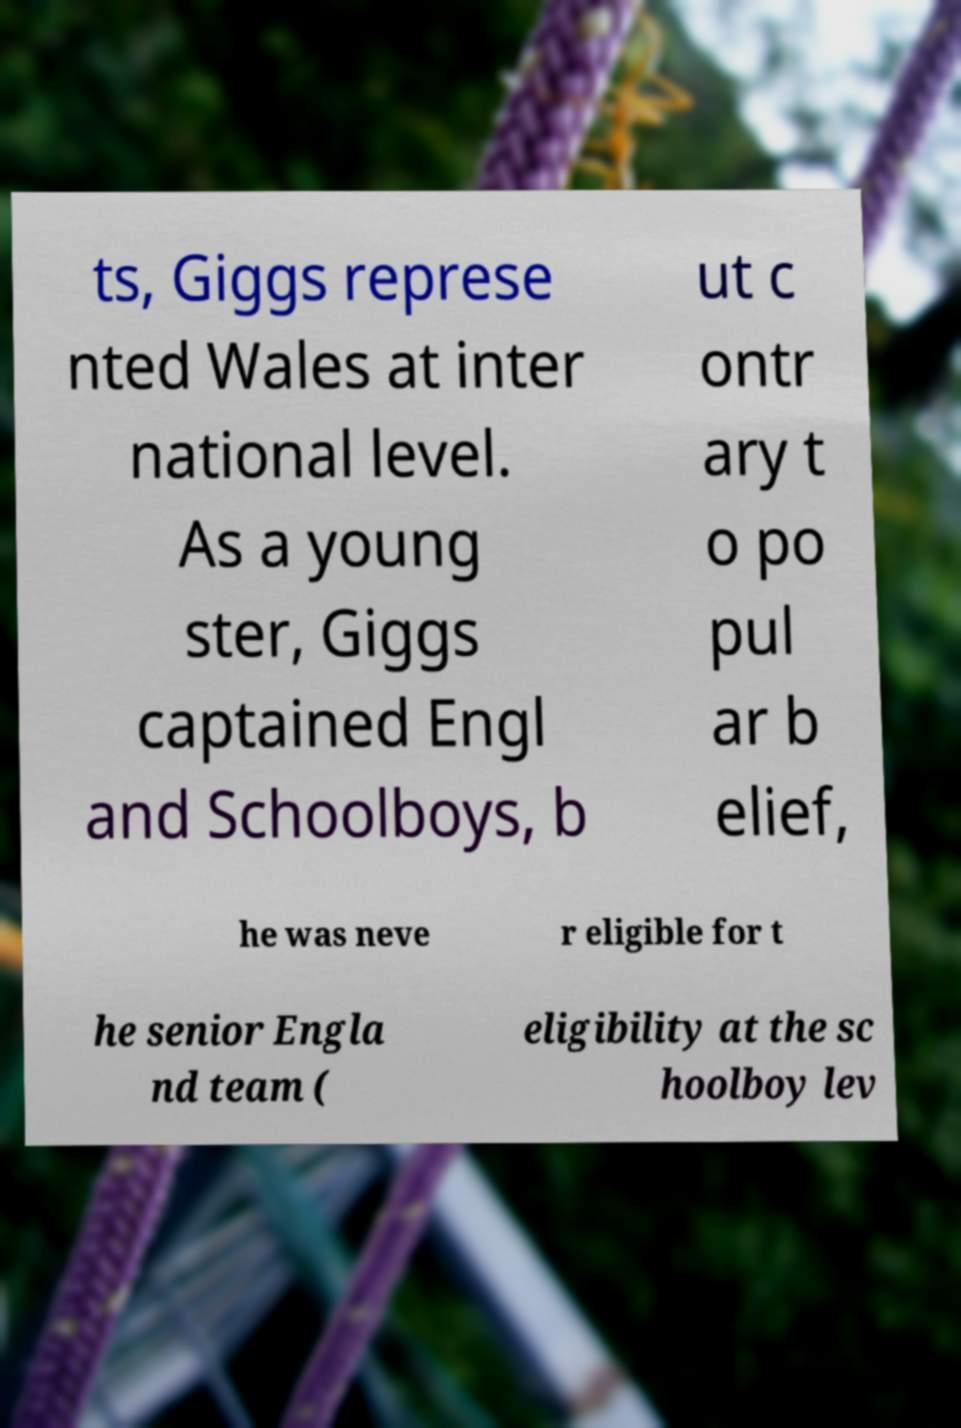Please read and relay the text visible in this image. What does it say? ts, Giggs represe nted Wales at inter national level. As a young ster, Giggs captained Engl and Schoolboys, b ut c ontr ary t o po pul ar b elief, he was neve r eligible for t he senior Engla nd team ( eligibility at the sc hoolboy lev 